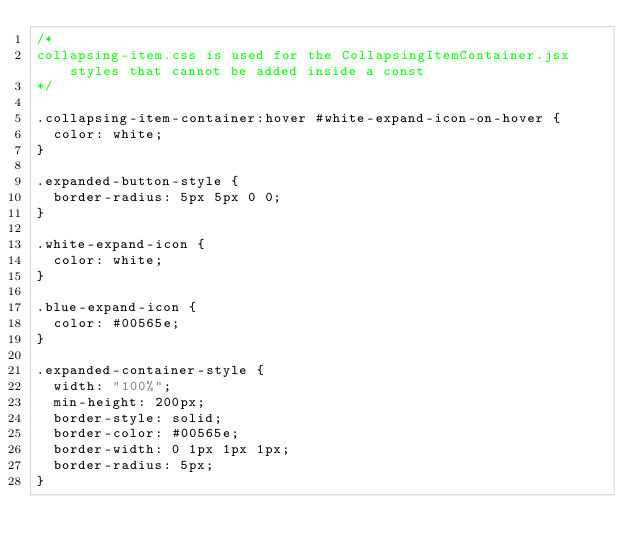Convert code to text. <code><loc_0><loc_0><loc_500><loc_500><_CSS_>/*
collapsing-item.css is used for the CollapsingItemContainer.jsx styles that cannot be added inside a const
*/

.collapsing-item-container:hover #white-expand-icon-on-hover {
  color: white;
}

.expanded-button-style {
  border-radius: 5px 5px 0 0;
}

.white-expand-icon {
  color: white;
}

.blue-expand-icon {
  color: #00565e;
}

.expanded-container-style {
  width: "100%";
  min-height: 200px;
  border-style: solid;
  border-color: #00565e;
  border-width: 0 1px 1px 1px;
  border-radius: 5px;
}
</code> 